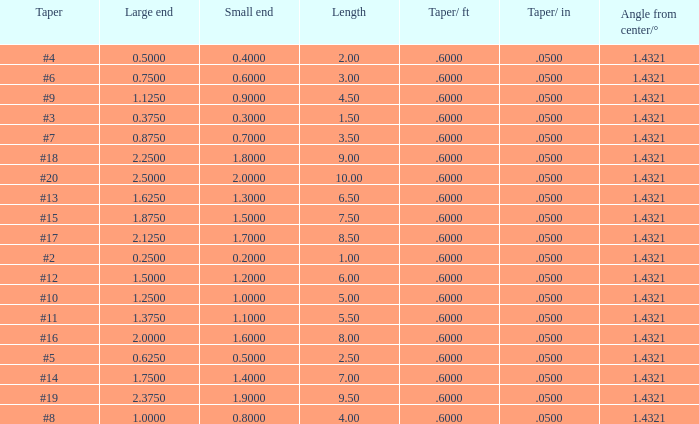Which Length has a Taper of #15, and a Large end larger than 1.875? None. 